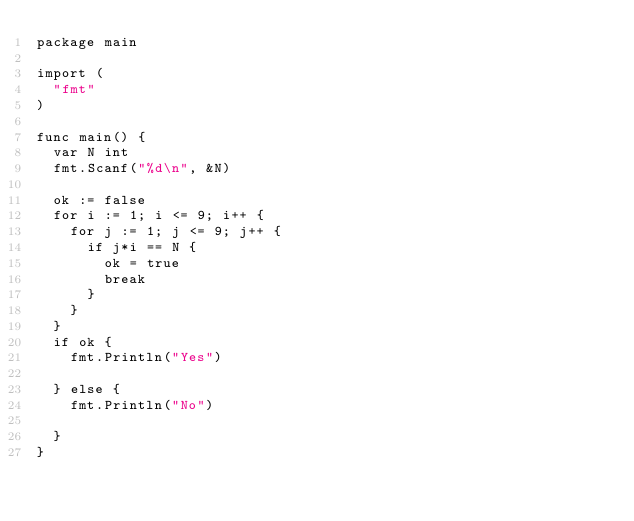Convert code to text. <code><loc_0><loc_0><loc_500><loc_500><_Go_>package main

import (
	"fmt"
)

func main() {
	var N int
	fmt.Scanf("%d\n", &N)

	ok := false
	for i := 1; i <= 9; i++ {
		for j := 1; j <= 9; j++ {
			if j*i == N {
				ok = true
				break
			}
		}
	}
	if ok {
		fmt.Println("Yes")

	} else {
		fmt.Println("No")

	}
}
</code> 